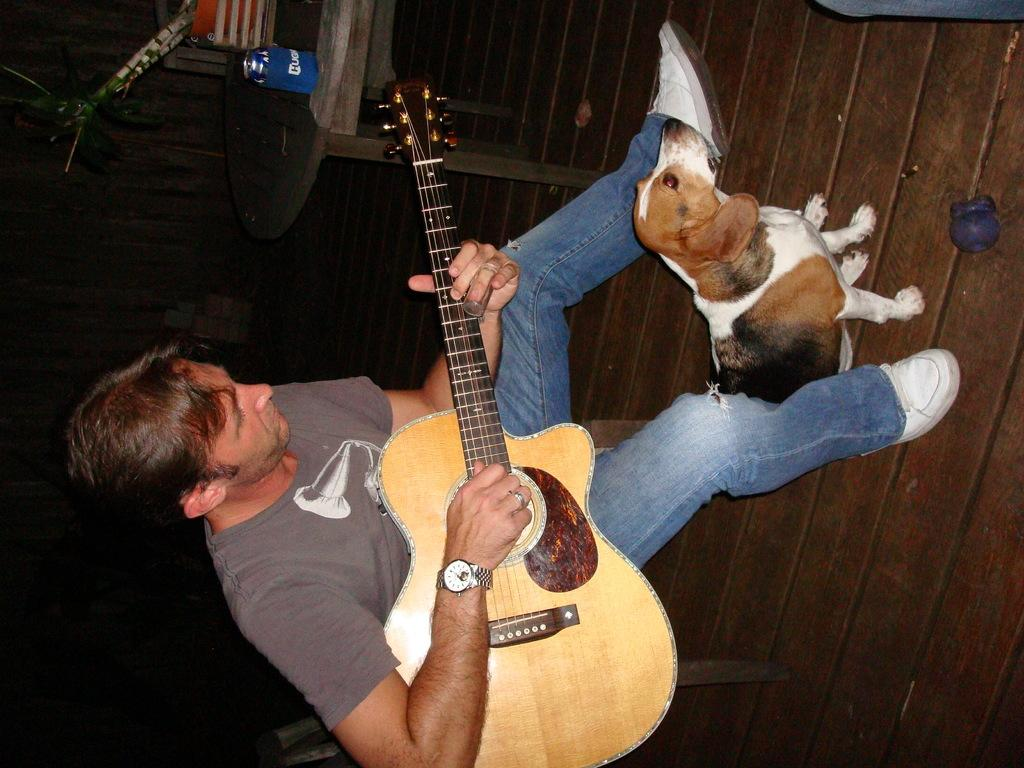What is the man in the image doing? The man is sitting and playing a guitar in the image. What is the small dog in the image doing? The small dog is sitting on the floor in the image. What type of furniture is present in the image? There is a wooden table in the image. What is on the wooden table? There is a bottle and other objects on the wooden table in the image. What is the floor made of in the image? The floor appears to be wooden in the image. What arithmetic problem is the man solving in the image? There is no indication in the image that the man is solving an arithmetic problem; he is playing a guitar. What is the actor doing in the image? There is no actor present in the image; the man playing the guitar is not an actor. 